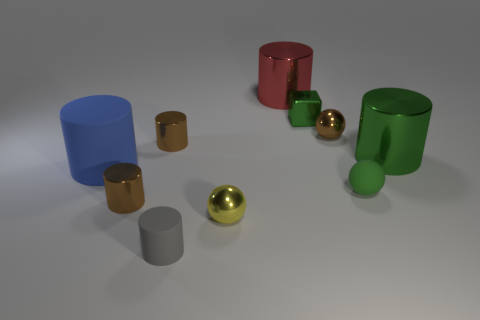Subtract all green metallic cylinders. How many cylinders are left? 5 Subtract all purple blocks. How many brown cylinders are left? 2 Subtract all red cylinders. How many cylinders are left? 5 Subtract all red spheres. Subtract all cyan cylinders. How many spheres are left? 3 Subtract all cubes. How many objects are left? 9 Add 2 green matte spheres. How many green matte spheres are left? 3 Add 6 tiny brown shiny blocks. How many tiny brown shiny blocks exist? 6 Subtract 0 blue blocks. How many objects are left? 10 Subtract all tiny green rubber balls. Subtract all big blue rubber cylinders. How many objects are left? 8 